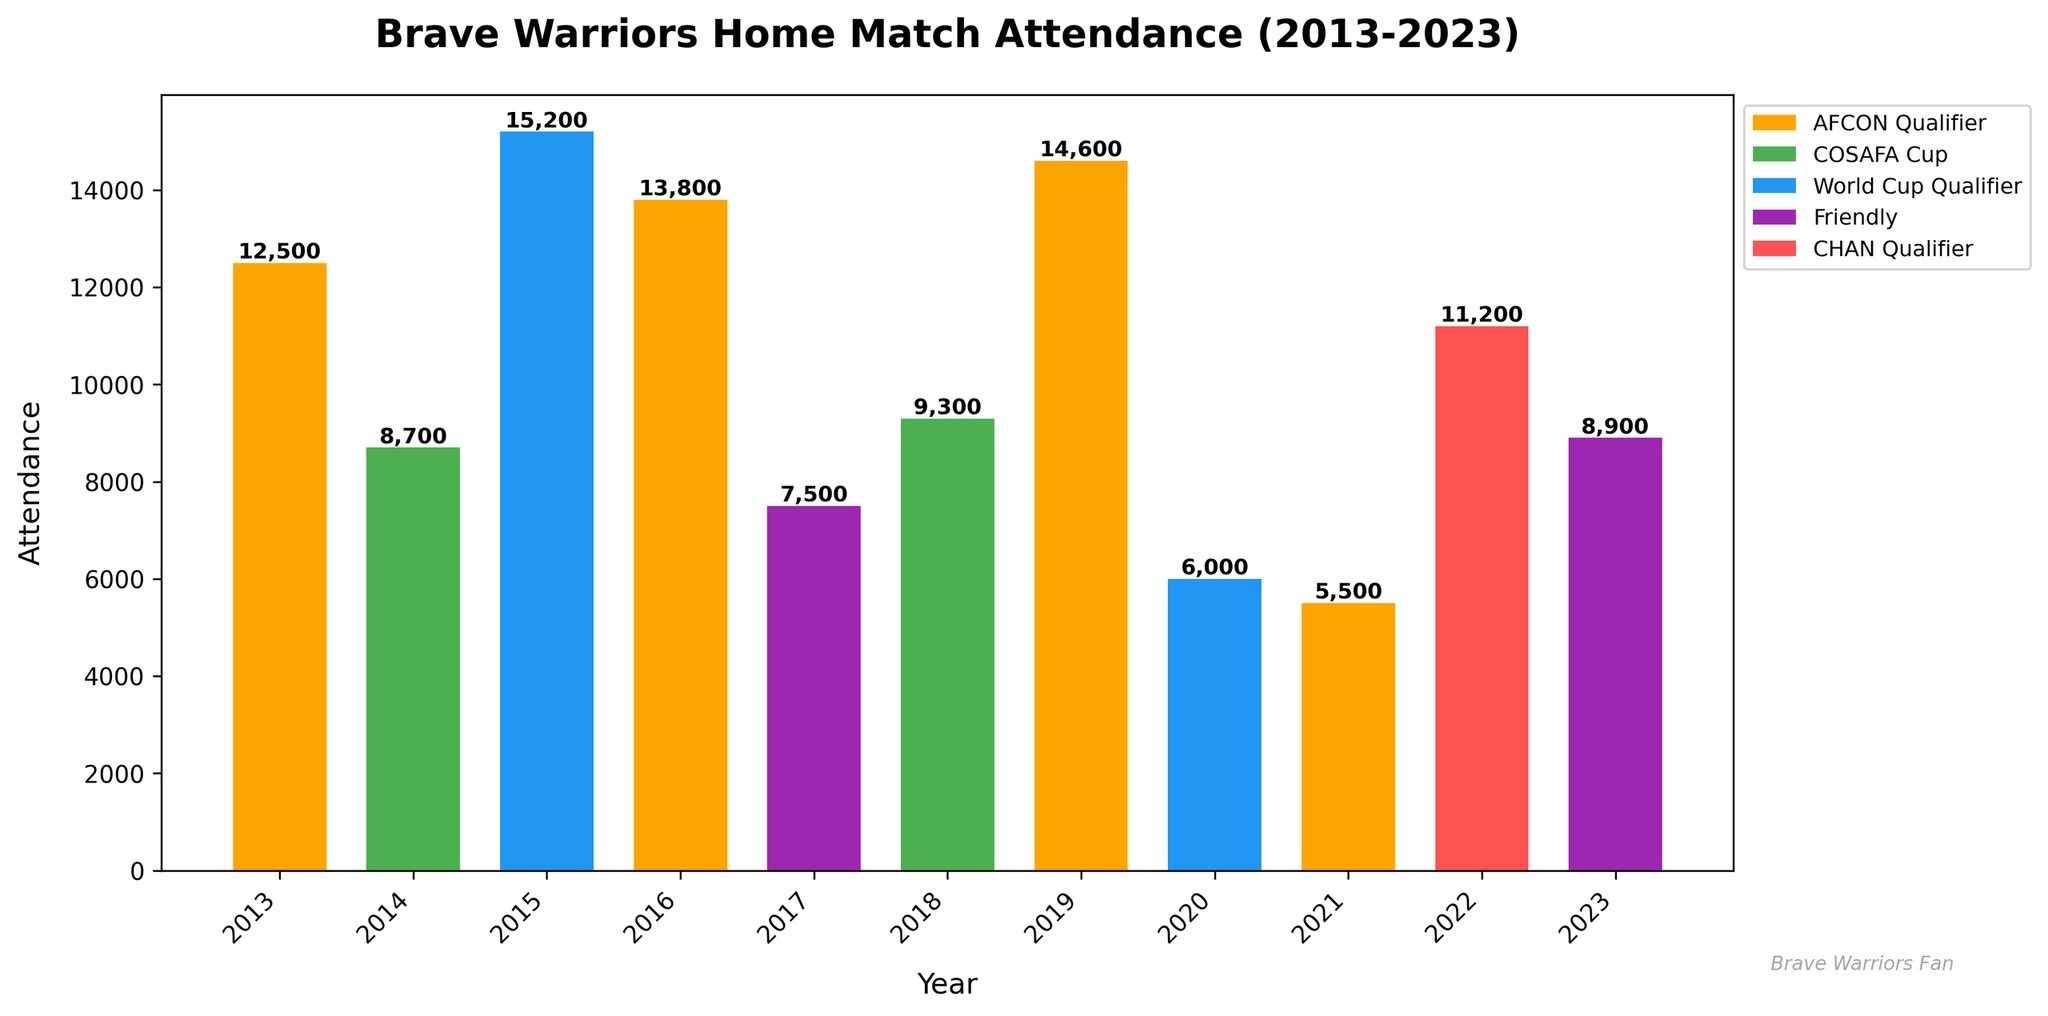What year had the highest attendance for a Brave Warriors' home match? To determine the year with the highest attendance, look for the tallest bar on the chart. The tallest bar, indicating the highest attendance, corresponds to the year 2015 with an attendance of 15,200 for a World Cup Qualifier.
Answer: 2015 Which competition type had the lowest attendance over the past 10 years? To identify the lowest attendance, look for the shortest bar on the chart and then identify the competition type. The shortest bar appears in the AFCON Qualifier in 2021 with an attendance of 5,500.
Answer: AFCON Qualifier What was the total attendance for Brave Warriors' AFCON Qualifier matches over the past 10 years? Sum the attendance values for all AFCON Qualifier matches. These values are: 12,500 (2013), 13,800 (2016), 14,600 (2019), and 5,500 (2021). Total = 12,500 + 13,800 + 14,600 + 5,500 = 46,400.
Answer: 46,400 How does the attendance for the 2020 World Cup Qualifier compare to the 2023 Friendly match? To compare, look at the heights of the bars for 2020 and 2023. The attendance in 2020 (6,000) for the World Cup Qualifier is less than the attendance in 2023 (8,900) for the Friendly match.
Answer: Less What is the average attendance for Brave Warriors' home matches in 2015 and 2016? Calculate the average attendance by summing the attendances for 2015 and 2016 and then dividing by 2. The attendances are 15,200 (2015) and 13,800 (2016). Sum = 15,200 + 13,800 = 29,000. Average = 29,000 / 2 = 14,500.
Answer: 14,500 Which years had attendances higher than 12,000? Look for bars that exceed the 12,000 mark and note their corresponding years. These years are 2013 (12,500), 2015 (15,200), 2016 (13,800), and 2019 (14,600).
Answer: 2013, 2015, 2016, 2019 What is the difference in attendance between the 2014 COSAFA Cup and the 2018 COSAFA Cup? Subtract the attendance of the 2014 COSAFA Cup (8,700) from the attendance of the 2018 COSAFA Cup (9,300). Difference = 9,300 - 8,700 = 600.
Answer: 600 Which competition type appears most frequently in the past 10 years' attendance data? Count the frequency of each competition type appearing on the chart. AFCON Qualifier appears in 2013, 2016, 2019, and 2021, which is the most frequent.
Answer: AFCON Qualifier What is the median attendance value for Brave Warriors' home matches over this period? Arrange the attendance values in ascending order and find the middle value. The sorted attendances are: 5,500, 6,000, 7,500, 8,700, 8,900, 9,300, 11,200, 12,500, 13,800, 14,600, 15,200. With 11 data points, the median is the 6th value, which is 9,300.
Answer: 9,300 What is the total attendance for Friendly matches over the past 10 years? Sum the attendance values for all Friendly matches. These values are: 7,500 (2017) and 8,900 (2023). Total = 7,500 + 8,900 = 16,400.
Answer: 16,400 